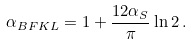<formula> <loc_0><loc_0><loc_500><loc_500>\alpha _ { B F K L } = 1 + \frac { 1 2 \alpha _ { S } } { \pi } \ln 2 \, .</formula> 